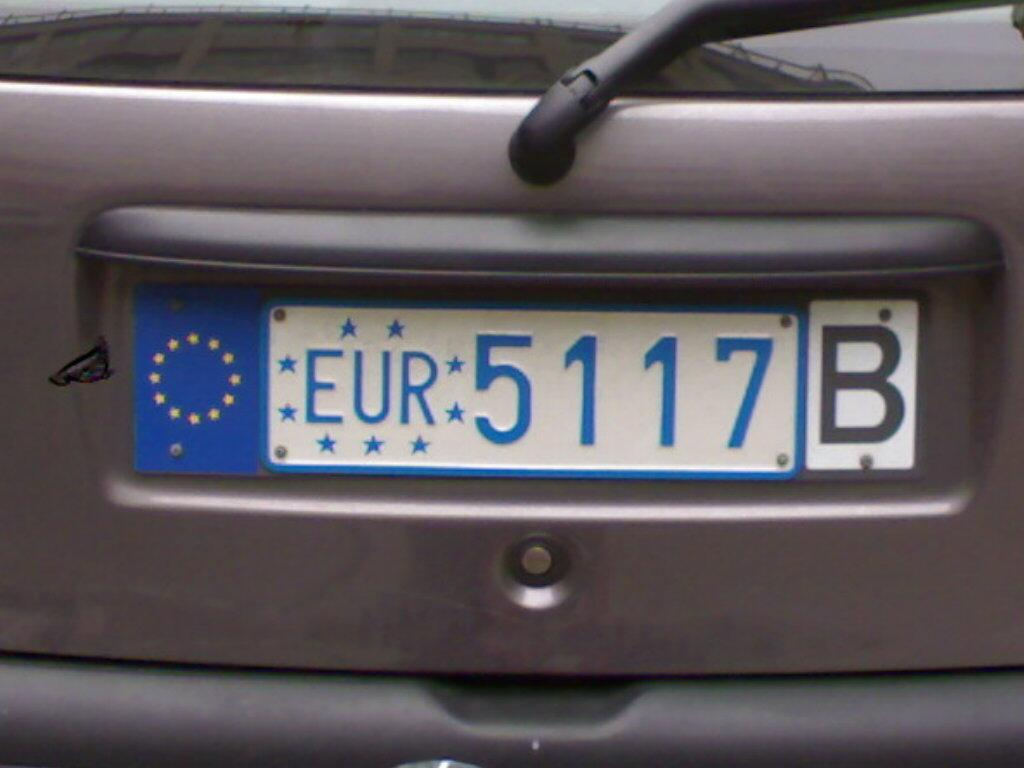What is the main subject of the image? The main subject of the image is a vehicle. Can you describe any specific features of the vehicle? Yes, the vehicle has a number plate. How many hearts can be seen on the vehicle in the image? There are no hearts visible on the vehicle in the image. Are the vehicle's owners, who are sisters, present in the image? There is no information about the vehicle's owners or their relationship in the image. 